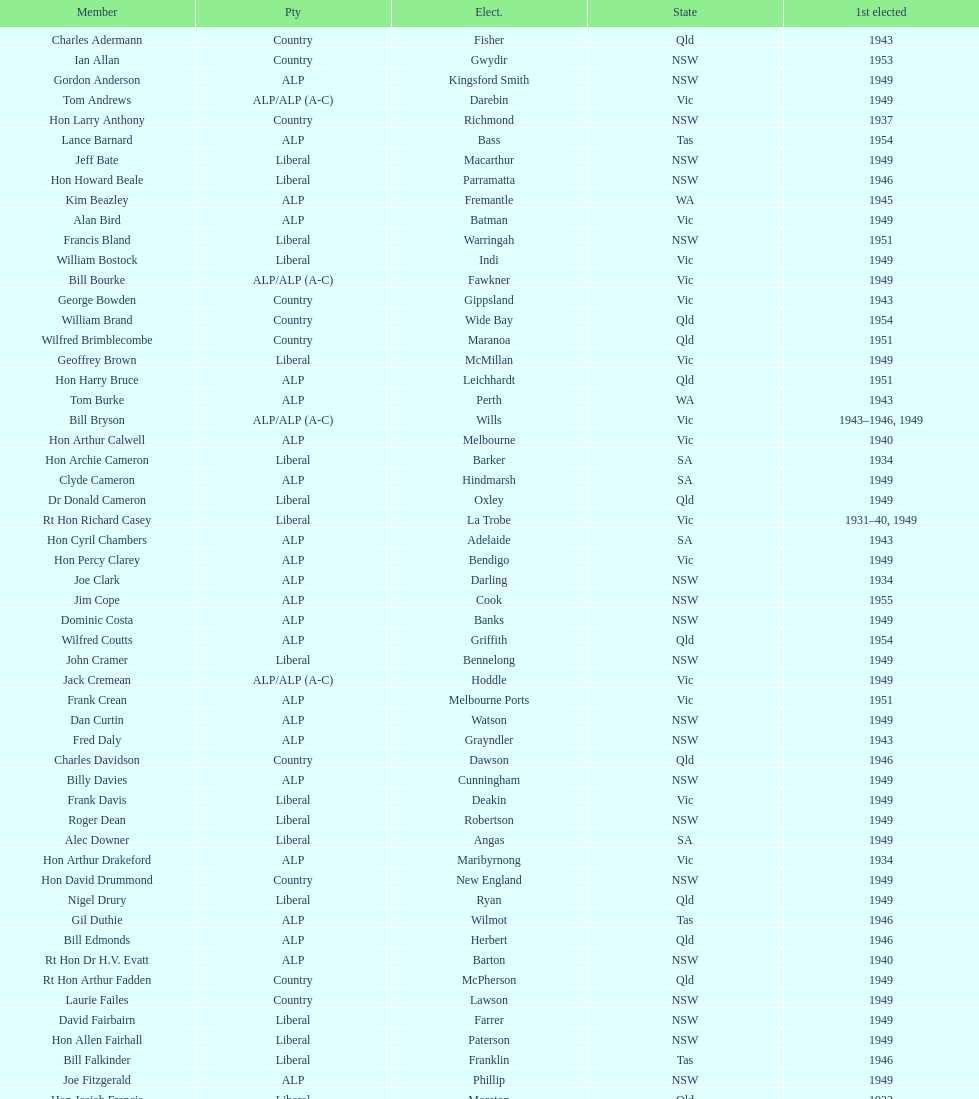What is the number of alp party members elected? 57. 